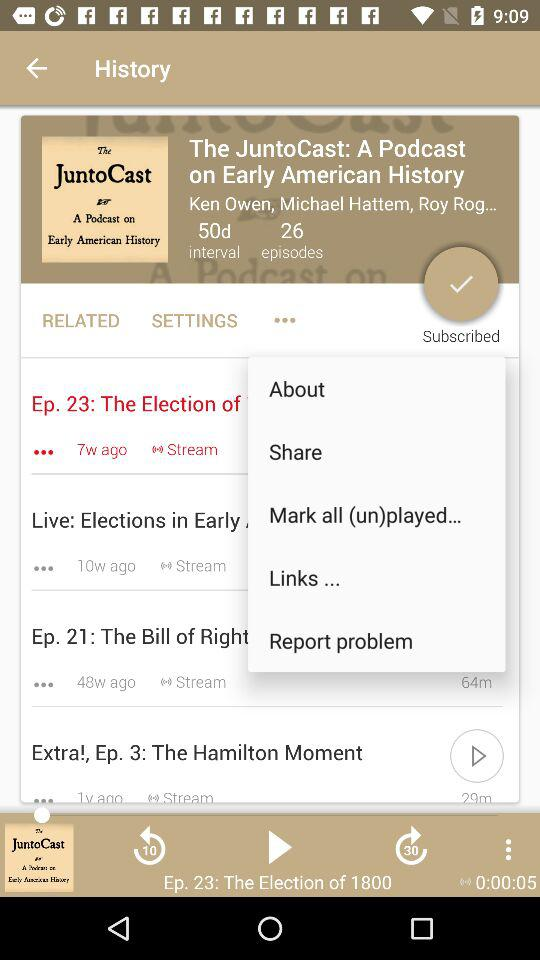How many episodes in total of "The JuntoCast" are there? There are 26 episodes in total of "The JuntoCast". 